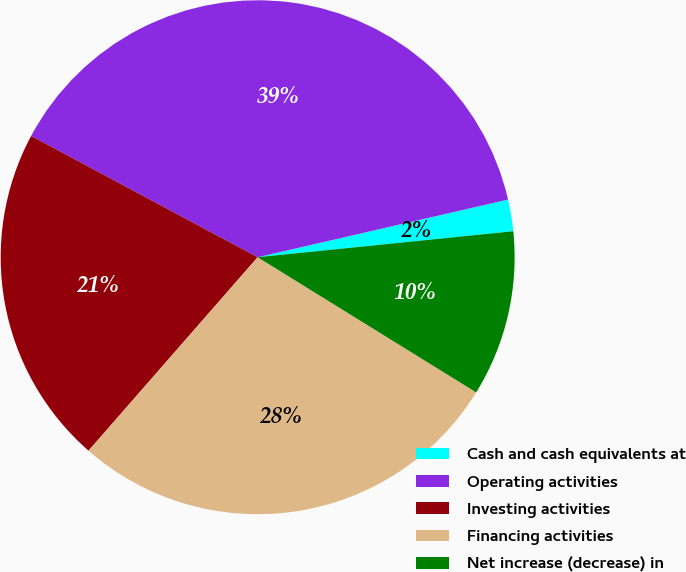<chart> <loc_0><loc_0><loc_500><loc_500><pie_chart><fcel>Cash and cash equivalents at<fcel>Operating activities<fcel>Investing activities<fcel>Financing activities<fcel>Net increase (decrease) in<nl><fcel>1.99%<fcel>38.58%<fcel>21.39%<fcel>27.62%<fcel>10.43%<nl></chart> 